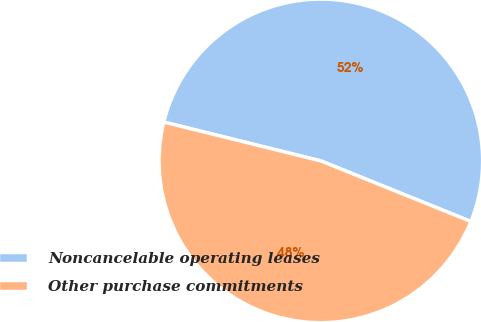Convert chart to OTSL. <chart><loc_0><loc_0><loc_500><loc_500><pie_chart><fcel>Noncancelable operating leases<fcel>Other purchase commitments<nl><fcel>52.25%<fcel>47.75%<nl></chart> 